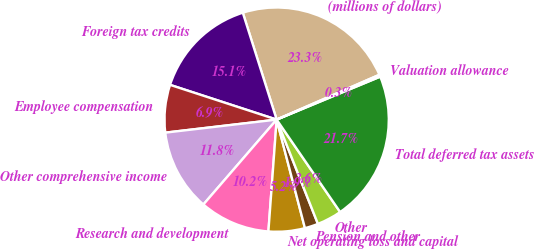<chart> <loc_0><loc_0><loc_500><loc_500><pie_chart><fcel>(millions of dollars)<fcel>Foreign tax credits<fcel>Employee compensation<fcel>Other comprehensive income<fcel>Research and development<fcel>Net operating loss and capital<fcel>Pension and other<fcel>Other<fcel>Total deferred tax assets<fcel>Valuation allowance<nl><fcel>23.33%<fcel>15.1%<fcel>6.87%<fcel>11.81%<fcel>10.16%<fcel>5.23%<fcel>1.94%<fcel>3.58%<fcel>21.68%<fcel>0.29%<nl></chart> 